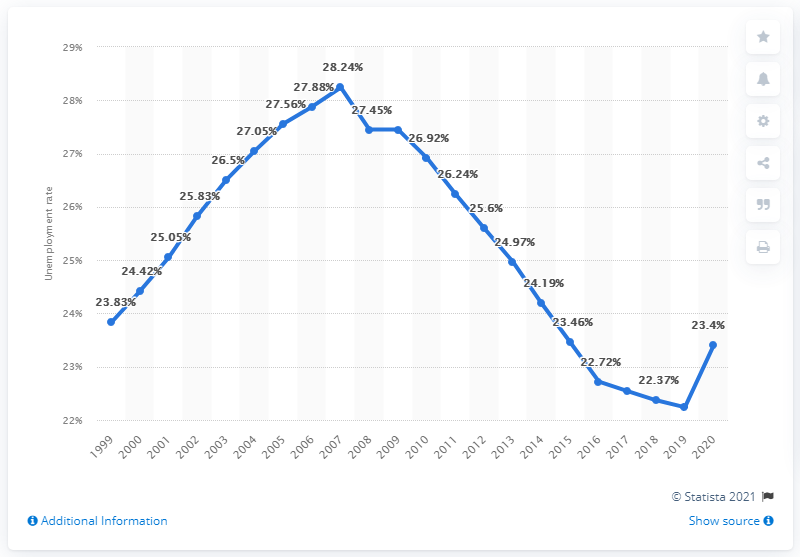Identify some key points in this picture. The unemployment rate in Swaziland in 2020 was 23.4%. 